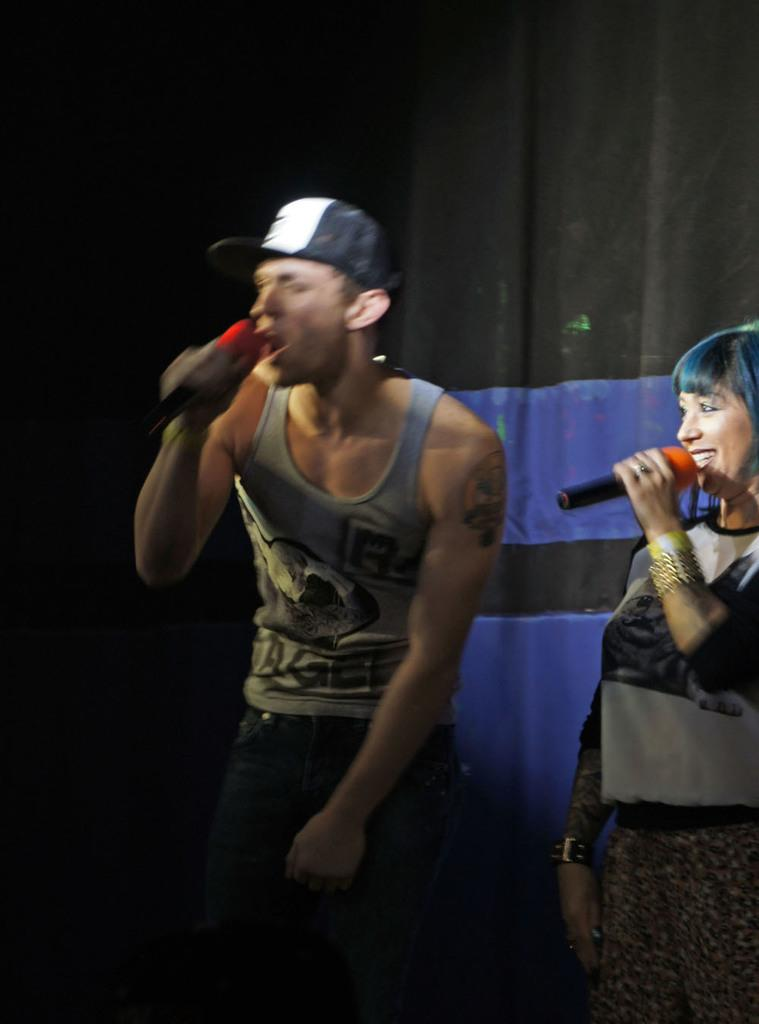What is the man in the image holding? The man is holding a mic in the image. What is the man doing with the mic? The man is singing in the image. What is the woman in the image holding? The woman is holding a mic in the image. What is the woman's expression in the image? The woman is smiling in the image. What can be seen in the background of the image? There is a curtain in the image. What year is the event depicted in the image taking place? There is no indication of a specific year or event in the image. What type of brush is the woman using to paint in the image? There is no brush present in the image; the woman is holding a mic and singing. 